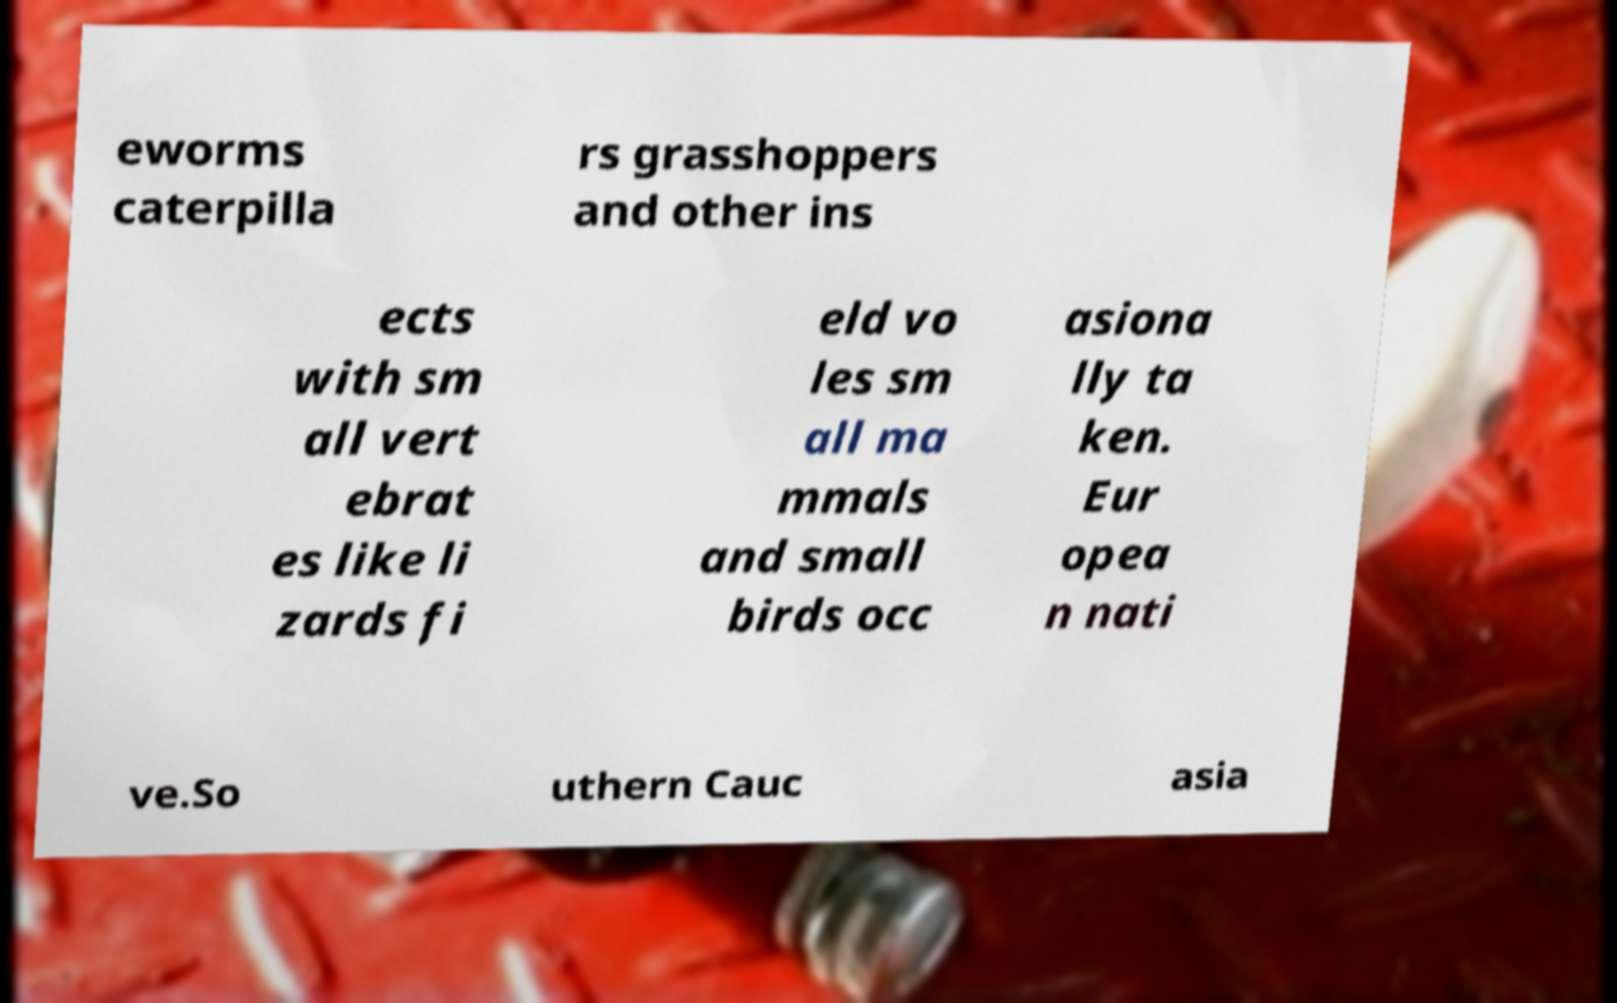I need the written content from this picture converted into text. Can you do that? eworms caterpilla rs grasshoppers and other ins ects with sm all vert ebrat es like li zards fi eld vo les sm all ma mmals and small birds occ asiona lly ta ken. Eur opea n nati ve.So uthern Cauc asia 